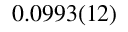<formula> <loc_0><loc_0><loc_500><loc_500>0 . 0 9 9 3 ( 1 2 )</formula> 